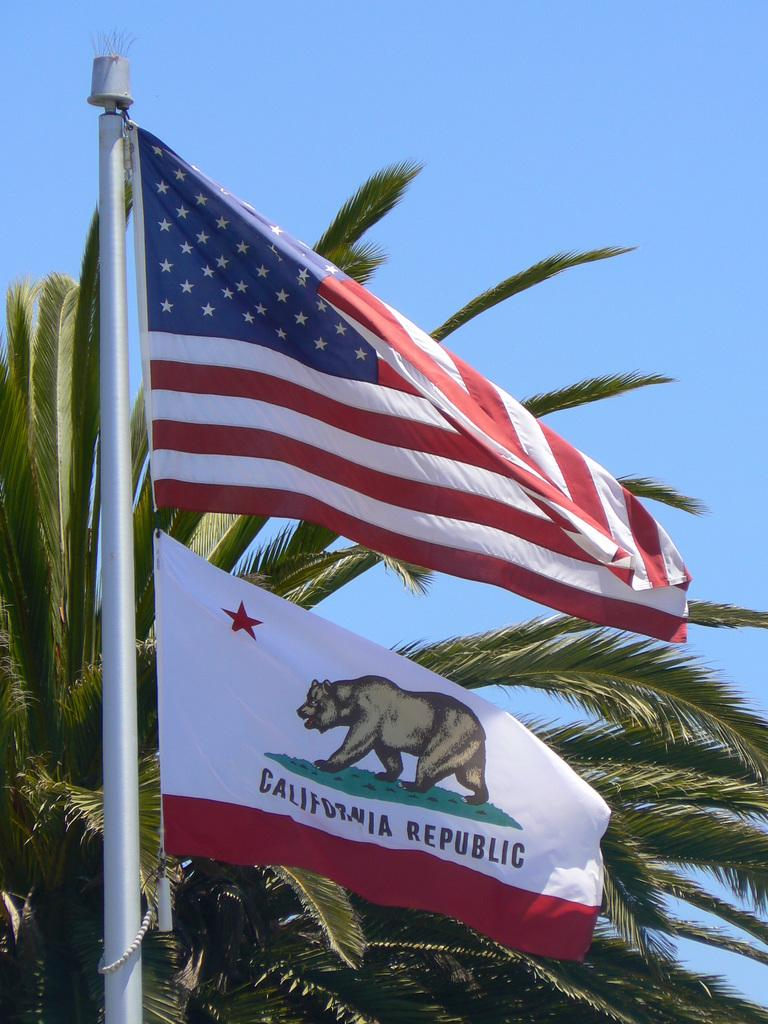How many flags are visible in the image? There are two flags in the image. Where are the flags located? The flags are attached to a pole. What can be seen in the background of the image? There are trees in the background of the image. What is the color of the trees? The trees are green. What is the color of the sky in the image? The sky is blue in the image. What type of news can be heard coming from the flags in the image? There is no indication in the image that the flags are related to news or any sounds, so it's not possible to determine what news might be heard. 